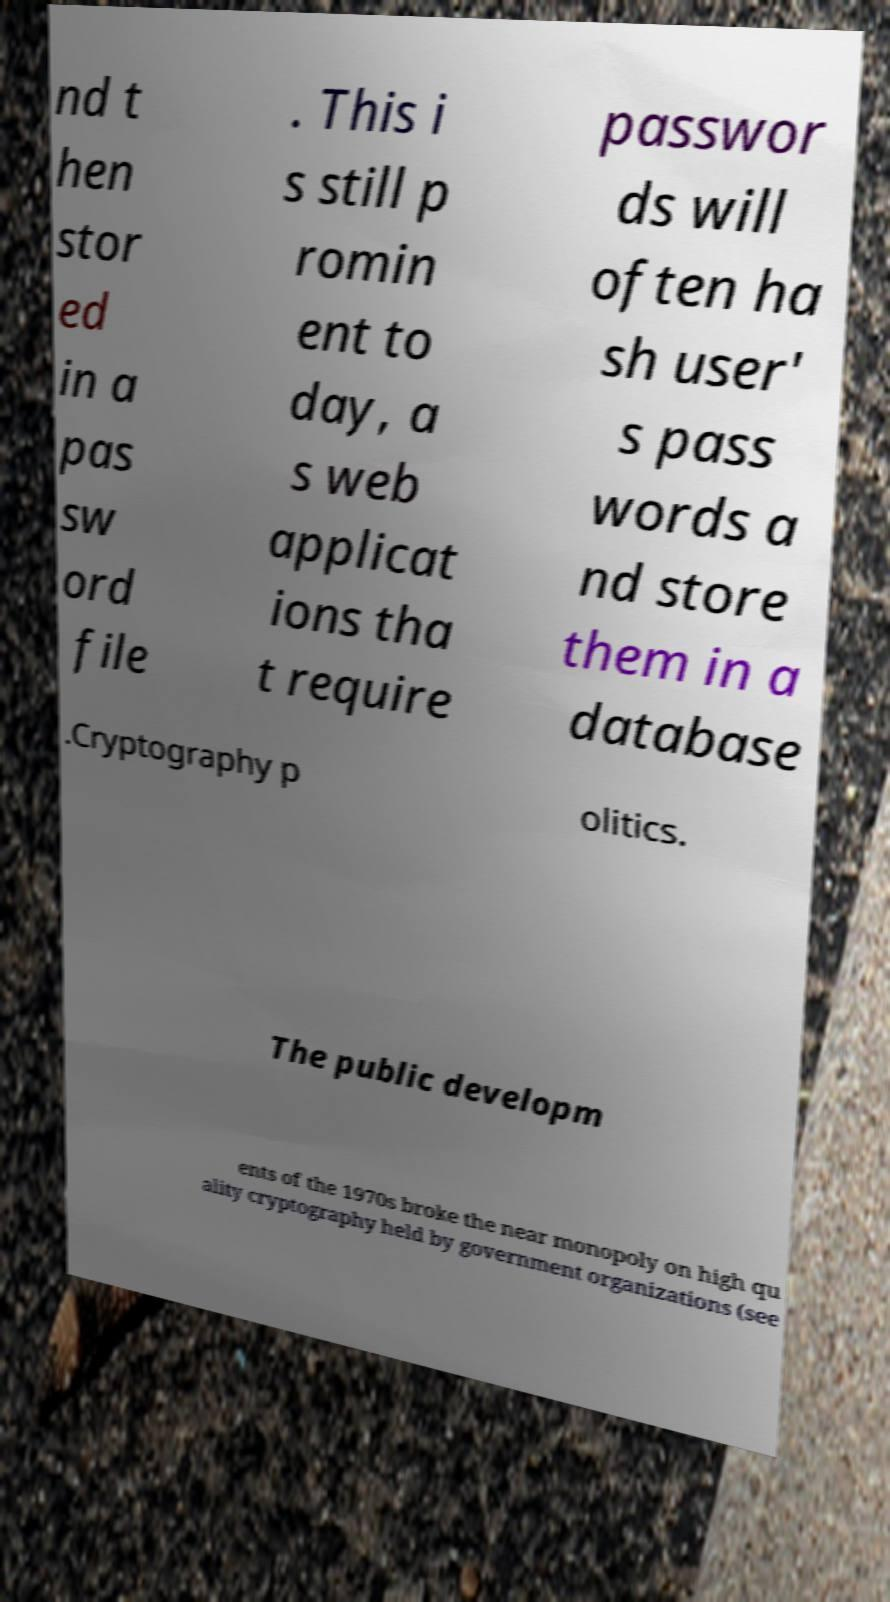Please identify and transcribe the text found in this image. nd t hen stor ed in a pas sw ord file . This i s still p romin ent to day, a s web applicat ions tha t require passwor ds will often ha sh user' s pass words a nd store them in a database .Cryptography p olitics. The public developm ents of the 1970s broke the near monopoly on high qu ality cryptography held by government organizations (see 